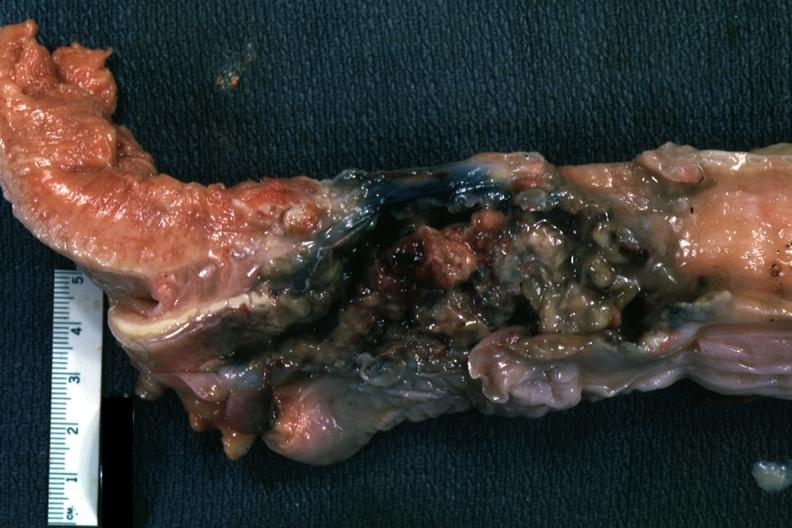what is larynx of necrotic tissue?
Answer the question using a single word or phrase. Mass 